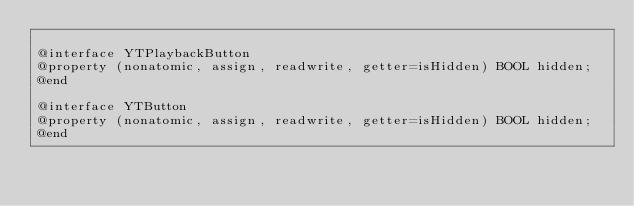<code> <loc_0><loc_0><loc_500><loc_500><_C_>
@interface YTPlaybackButton
@property (nonatomic, assign, readwrite, getter=isHidden) BOOL hidden;
@end

@interface YTButton
@property (nonatomic, assign, readwrite, getter=isHidden) BOOL hidden;
@end
</code> 